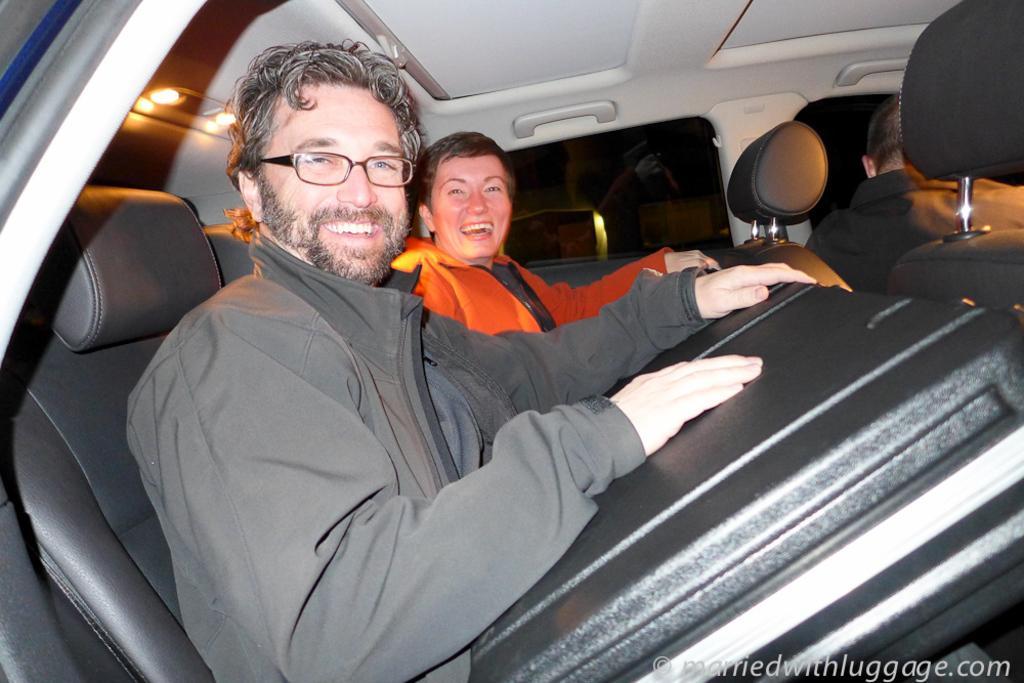Please provide a concise description of this image. There is a person in orange color shirt and a person in gray color coat smiling and sitting on the seat of a vehicle. And the background is dark in color. 